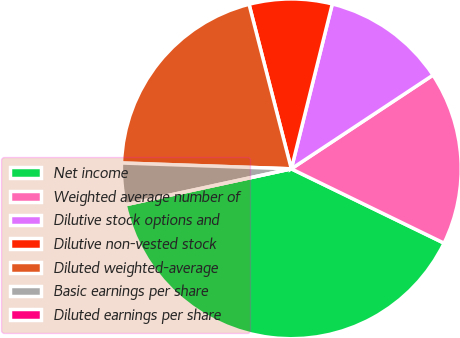Convert chart. <chart><loc_0><loc_0><loc_500><loc_500><pie_chart><fcel>Net income<fcel>Weighted average number of<fcel>Dilutive stock options and<fcel>Dilutive non-vested stock<fcel>Diluted weighted-average<fcel>Basic earnings per share<fcel>Diluted earnings per share<nl><fcel>39.4%<fcel>16.51%<fcel>11.82%<fcel>7.88%<fcel>20.45%<fcel>3.94%<fcel>0.0%<nl></chart> 